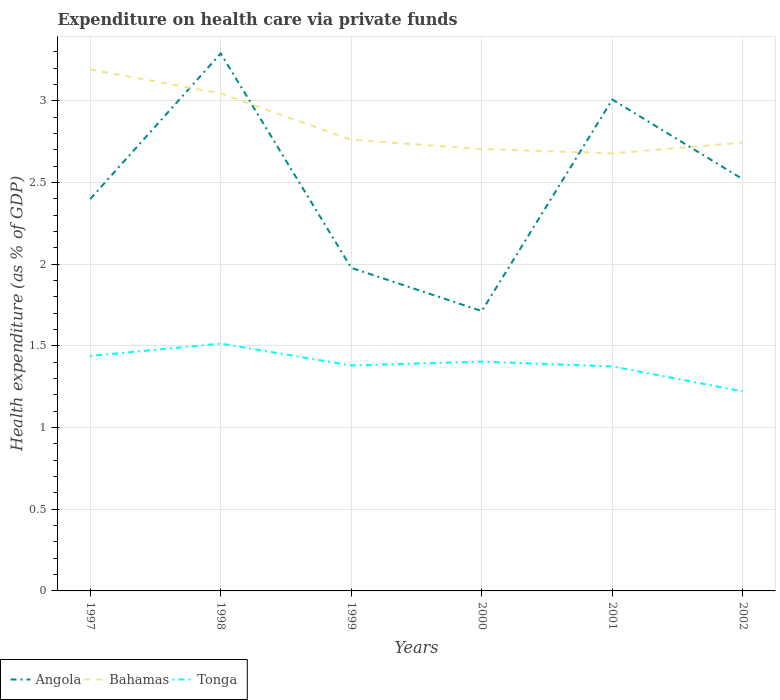Does the line corresponding to Angola intersect with the line corresponding to Bahamas?
Make the answer very short. Yes. Across all years, what is the maximum expenditure made on health care in Angola?
Provide a succinct answer. 1.71. In which year was the expenditure made on health care in Bahamas maximum?
Offer a terse response. 2001. What is the total expenditure made on health care in Bahamas in the graph?
Make the answer very short. 0.34. What is the difference between the highest and the second highest expenditure made on health care in Bahamas?
Your answer should be very brief. 0.51. How many years are there in the graph?
Provide a succinct answer. 6. Does the graph contain any zero values?
Offer a very short reply. No. Where does the legend appear in the graph?
Make the answer very short. Bottom left. How many legend labels are there?
Offer a terse response. 3. How are the legend labels stacked?
Provide a succinct answer. Horizontal. What is the title of the graph?
Offer a very short reply. Expenditure on health care via private funds. What is the label or title of the Y-axis?
Provide a short and direct response. Health expenditure (as % of GDP). What is the Health expenditure (as % of GDP) in Angola in 1997?
Offer a terse response. 2.4. What is the Health expenditure (as % of GDP) in Bahamas in 1997?
Offer a very short reply. 3.19. What is the Health expenditure (as % of GDP) in Tonga in 1997?
Your response must be concise. 1.44. What is the Health expenditure (as % of GDP) of Angola in 1998?
Provide a short and direct response. 3.29. What is the Health expenditure (as % of GDP) of Bahamas in 1998?
Make the answer very short. 3.05. What is the Health expenditure (as % of GDP) of Tonga in 1998?
Provide a succinct answer. 1.51. What is the Health expenditure (as % of GDP) in Angola in 1999?
Provide a succinct answer. 1.98. What is the Health expenditure (as % of GDP) in Bahamas in 1999?
Your answer should be very brief. 2.76. What is the Health expenditure (as % of GDP) of Tonga in 1999?
Offer a terse response. 1.38. What is the Health expenditure (as % of GDP) of Angola in 2000?
Keep it short and to the point. 1.71. What is the Health expenditure (as % of GDP) of Bahamas in 2000?
Your answer should be compact. 2.71. What is the Health expenditure (as % of GDP) in Tonga in 2000?
Keep it short and to the point. 1.4. What is the Health expenditure (as % of GDP) in Angola in 2001?
Keep it short and to the point. 3.01. What is the Health expenditure (as % of GDP) in Bahamas in 2001?
Make the answer very short. 2.68. What is the Health expenditure (as % of GDP) in Tonga in 2001?
Make the answer very short. 1.37. What is the Health expenditure (as % of GDP) in Angola in 2002?
Your response must be concise. 2.52. What is the Health expenditure (as % of GDP) in Bahamas in 2002?
Offer a terse response. 2.75. What is the Health expenditure (as % of GDP) of Tonga in 2002?
Give a very brief answer. 1.22. Across all years, what is the maximum Health expenditure (as % of GDP) of Angola?
Provide a short and direct response. 3.29. Across all years, what is the maximum Health expenditure (as % of GDP) of Bahamas?
Your response must be concise. 3.19. Across all years, what is the maximum Health expenditure (as % of GDP) in Tonga?
Ensure brevity in your answer.  1.51. Across all years, what is the minimum Health expenditure (as % of GDP) of Angola?
Your answer should be very brief. 1.71. Across all years, what is the minimum Health expenditure (as % of GDP) of Bahamas?
Offer a terse response. 2.68. Across all years, what is the minimum Health expenditure (as % of GDP) in Tonga?
Provide a short and direct response. 1.22. What is the total Health expenditure (as % of GDP) of Angola in the graph?
Make the answer very short. 14.91. What is the total Health expenditure (as % of GDP) in Bahamas in the graph?
Your answer should be very brief. 17.13. What is the total Health expenditure (as % of GDP) in Tonga in the graph?
Make the answer very short. 8.33. What is the difference between the Health expenditure (as % of GDP) of Angola in 1997 and that in 1998?
Offer a very short reply. -0.89. What is the difference between the Health expenditure (as % of GDP) in Bahamas in 1997 and that in 1998?
Your answer should be compact. 0.15. What is the difference between the Health expenditure (as % of GDP) in Tonga in 1997 and that in 1998?
Your response must be concise. -0.08. What is the difference between the Health expenditure (as % of GDP) of Angola in 1997 and that in 1999?
Your answer should be compact. 0.42. What is the difference between the Health expenditure (as % of GDP) in Bahamas in 1997 and that in 1999?
Make the answer very short. 0.43. What is the difference between the Health expenditure (as % of GDP) in Tonga in 1997 and that in 1999?
Your answer should be very brief. 0.06. What is the difference between the Health expenditure (as % of GDP) of Angola in 1997 and that in 2000?
Keep it short and to the point. 0.69. What is the difference between the Health expenditure (as % of GDP) of Bahamas in 1997 and that in 2000?
Give a very brief answer. 0.49. What is the difference between the Health expenditure (as % of GDP) of Tonga in 1997 and that in 2000?
Provide a succinct answer. 0.03. What is the difference between the Health expenditure (as % of GDP) in Angola in 1997 and that in 2001?
Your answer should be compact. -0.61. What is the difference between the Health expenditure (as % of GDP) in Bahamas in 1997 and that in 2001?
Provide a short and direct response. 0.51. What is the difference between the Health expenditure (as % of GDP) in Tonga in 1997 and that in 2001?
Ensure brevity in your answer.  0.06. What is the difference between the Health expenditure (as % of GDP) of Angola in 1997 and that in 2002?
Your response must be concise. -0.12. What is the difference between the Health expenditure (as % of GDP) of Bahamas in 1997 and that in 2002?
Ensure brevity in your answer.  0.45. What is the difference between the Health expenditure (as % of GDP) of Tonga in 1997 and that in 2002?
Provide a succinct answer. 0.22. What is the difference between the Health expenditure (as % of GDP) in Angola in 1998 and that in 1999?
Ensure brevity in your answer.  1.31. What is the difference between the Health expenditure (as % of GDP) in Bahamas in 1998 and that in 1999?
Give a very brief answer. 0.28. What is the difference between the Health expenditure (as % of GDP) in Tonga in 1998 and that in 1999?
Your answer should be compact. 0.13. What is the difference between the Health expenditure (as % of GDP) of Angola in 1998 and that in 2000?
Your answer should be compact. 1.58. What is the difference between the Health expenditure (as % of GDP) in Bahamas in 1998 and that in 2000?
Make the answer very short. 0.34. What is the difference between the Health expenditure (as % of GDP) in Tonga in 1998 and that in 2000?
Keep it short and to the point. 0.11. What is the difference between the Health expenditure (as % of GDP) in Angola in 1998 and that in 2001?
Provide a succinct answer. 0.28. What is the difference between the Health expenditure (as % of GDP) in Bahamas in 1998 and that in 2001?
Your answer should be very brief. 0.37. What is the difference between the Health expenditure (as % of GDP) of Tonga in 1998 and that in 2001?
Your response must be concise. 0.14. What is the difference between the Health expenditure (as % of GDP) in Angola in 1998 and that in 2002?
Your answer should be compact. 0.77. What is the difference between the Health expenditure (as % of GDP) of Bahamas in 1998 and that in 2002?
Your answer should be very brief. 0.3. What is the difference between the Health expenditure (as % of GDP) of Tonga in 1998 and that in 2002?
Provide a succinct answer. 0.29. What is the difference between the Health expenditure (as % of GDP) in Angola in 1999 and that in 2000?
Your answer should be very brief. 0.26. What is the difference between the Health expenditure (as % of GDP) in Bahamas in 1999 and that in 2000?
Offer a terse response. 0.06. What is the difference between the Health expenditure (as % of GDP) of Tonga in 1999 and that in 2000?
Offer a very short reply. -0.02. What is the difference between the Health expenditure (as % of GDP) in Angola in 1999 and that in 2001?
Ensure brevity in your answer.  -1.03. What is the difference between the Health expenditure (as % of GDP) in Bahamas in 1999 and that in 2001?
Provide a short and direct response. 0.08. What is the difference between the Health expenditure (as % of GDP) in Tonga in 1999 and that in 2001?
Give a very brief answer. 0.01. What is the difference between the Health expenditure (as % of GDP) in Angola in 1999 and that in 2002?
Keep it short and to the point. -0.54. What is the difference between the Health expenditure (as % of GDP) of Bahamas in 1999 and that in 2002?
Make the answer very short. 0.02. What is the difference between the Health expenditure (as % of GDP) of Tonga in 1999 and that in 2002?
Your answer should be very brief. 0.16. What is the difference between the Health expenditure (as % of GDP) of Angola in 2000 and that in 2001?
Offer a very short reply. -1.3. What is the difference between the Health expenditure (as % of GDP) in Bahamas in 2000 and that in 2001?
Your answer should be compact. 0.03. What is the difference between the Health expenditure (as % of GDP) in Tonga in 2000 and that in 2001?
Offer a terse response. 0.03. What is the difference between the Health expenditure (as % of GDP) in Angola in 2000 and that in 2002?
Your response must be concise. -0.81. What is the difference between the Health expenditure (as % of GDP) of Bahamas in 2000 and that in 2002?
Offer a very short reply. -0.04. What is the difference between the Health expenditure (as % of GDP) in Tonga in 2000 and that in 2002?
Keep it short and to the point. 0.18. What is the difference between the Health expenditure (as % of GDP) of Angola in 2001 and that in 2002?
Make the answer very short. 0.49. What is the difference between the Health expenditure (as % of GDP) of Bahamas in 2001 and that in 2002?
Give a very brief answer. -0.07. What is the difference between the Health expenditure (as % of GDP) of Tonga in 2001 and that in 2002?
Your answer should be compact. 0.15. What is the difference between the Health expenditure (as % of GDP) of Angola in 1997 and the Health expenditure (as % of GDP) of Bahamas in 1998?
Your response must be concise. -0.65. What is the difference between the Health expenditure (as % of GDP) in Angola in 1997 and the Health expenditure (as % of GDP) in Tonga in 1998?
Give a very brief answer. 0.89. What is the difference between the Health expenditure (as % of GDP) of Bahamas in 1997 and the Health expenditure (as % of GDP) of Tonga in 1998?
Offer a terse response. 1.68. What is the difference between the Health expenditure (as % of GDP) in Angola in 1997 and the Health expenditure (as % of GDP) in Bahamas in 1999?
Your answer should be compact. -0.36. What is the difference between the Health expenditure (as % of GDP) in Angola in 1997 and the Health expenditure (as % of GDP) in Tonga in 1999?
Keep it short and to the point. 1.02. What is the difference between the Health expenditure (as % of GDP) in Bahamas in 1997 and the Health expenditure (as % of GDP) in Tonga in 1999?
Provide a succinct answer. 1.81. What is the difference between the Health expenditure (as % of GDP) of Angola in 1997 and the Health expenditure (as % of GDP) of Bahamas in 2000?
Provide a short and direct response. -0.31. What is the difference between the Health expenditure (as % of GDP) in Bahamas in 1997 and the Health expenditure (as % of GDP) in Tonga in 2000?
Make the answer very short. 1.79. What is the difference between the Health expenditure (as % of GDP) of Angola in 1997 and the Health expenditure (as % of GDP) of Bahamas in 2001?
Make the answer very short. -0.28. What is the difference between the Health expenditure (as % of GDP) of Bahamas in 1997 and the Health expenditure (as % of GDP) of Tonga in 2001?
Offer a very short reply. 1.82. What is the difference between the Health expenditure (as % of GDP) of Angola in 1997 and the Health expenditure (as % of GDP) of Bahamas in 2002?
Your answer should be very brief. -0.35. What is the difference between the Health expenditure (as % of GDP) of Angola in 1997 and the Health expenditure (as % of GDP) of Tonga in 2002?
Give a very brief answer. 1.18. What is the difference between the Health expenditure (as % of GDP) in Bahamas in 1997 and the Health expenditure (as % of GDP) in Tonga in 2002?
Your answer should be compact. 1.97. What is the difference between the Health expenditure (as % of GDP) in Angola in 1998 and the Health expenditure (as % of GDP) in Bahamas in 1999?
Keep it short and to the point. 0.53. What is the difference between the Health expenditure (as % of GDP) of Angola in 1998 and the Health expenditure (as % of GDP) of Tonga in 1999?
Offer a very short reply. 1.91. What is the difference between the Health expenditure (as % of GDP) of Bahamas in 1998 and the Health expenditure (as % of GDP) of Tonga in 1999?
Offer a very short reply. 1.67. What is the difference between the Health expenditure (as % of GDP) of Angola in 1998 and the Health expenditure (as % of GDP) of Bahamas in 2000?
Give a very brief answer. 0.59. What is the difference between the Health expenditure (as % of GDP) in Angola in 1998 and the Health expenditure (as % of GDP) in Tonga in 2000?
Keep it short and to the point. 1.89. What is the difference between the Health expenditure (as % of GDP) in Bahamas in 1998 and the Health expenditure (as % of GDP) in Tonga in 2000?
Your response must be concise. 1.64. What is the difference between the Health expenditure (as % of GDP) of Angola in 1998 and the Health expenditure (as % of GDP) of Bahamas in 2001?
Your answer should be very brief. 0.61. What is the difference between the Health expenditure (as % of GDP) of Angola in 1998 and the Health expenditure (as % of GDP) of Tonga in 2001?
Your response must be concise. 1.92. What is the difference between the Health expenditure (as % of GDP) of Bahamas in 1998 and the Health expenditure (as % of GDP) of Tonga in 2001?
Provide a succinct answer. 1.67. What is the difference between the Health expenditure (as % of GDP) of Angola in 1998 and the Health expenditure (as % of GDP) of Bahamas in 2002?
Give a very brief answer. 0.55. What is the difference between the Health expenditure (as % of GDP) of Angola in 1998 and the Health expenditure (as % of GDP) of Tonga in 2002?
Provide a succinct answer. 2.07. What is the difference between the Health expenditure (as % of GDP) in Bahamas in 1998 and the Health expenditure (as % of GDP) in Tonga in 2002?
Keep it short and to the point. 1.82. What is the difference between the Health expenditure (as % of GDP) in Angola in 1999 and the Health expenditure (as % of GDP) in Bahamas in 2000?
Ensure brevity in your answer.  -0.73. What is the difference between the Health expenditure (as % of GDP) of Angola in 1999 and the Health expenditure (as % of GDP) of Tonga in 2000?
Make the answer very short. 0.57. What is the difference between the Health expenditure (as % of GDP) in Bahamas in 1999 and the Health expenditure (as % of GDP) in Tonga in 2000?
Your answer should be compact. 1.36. What is the difference between the Health expenditure (as % of GDP) of Angola in 1999 and the Health expenditure (as % of GDP) of Bahamas in 2001?
Ensure brevity in your answer.  -0.7. What is the difference between the Health expenditure (as % of GDP) of Angola in 1999 and the Health expenditure (as % of GDP) of Tonga in 2001?
Provide a short and direct response. 0.6. What is the difference between the Health expenditure (as % of GDP) of Bahamas in 1999 and the Health expenditure (as % of GDP) of Tonga in 2001?
Keep it short and to the point. 1.39. What is the difference between the Health expenditure (as % of GDP) in Angola in 1999 and the Health expenditure (as % of GDP) in Bahamas in 2002?
Your answer should be compact. -0.77. What is the difference between the Health expenditure (as % of GDP) of Angola in 1999 and the Health expenditure (as % of GDP) of Tonga in 2002?
Keep it short and to the point. 0.76. What is the difference between the Health expenditure (as % of GDP) of Bahamas in 1999 and the Health expenditure (as % of GDP) of Tonga in 2002?
Offer a terse response. 1.54. What is the difference between the Health expenditure (as % of GDP) of Angola in 2000 and the Health expenditure (as % of GDP) of Bahamas in 2001?
Your response must be concise. -0.97. What is the difference between the Health expenditure (as % of GDP) in Angola in 2000 and the Health expenditure (as % of GDP) in Tonga in 2001?
Your answer should be compact. 0.34. What is the difference between the Health expenditure (as % of GDP) in Bahamas in 2000 and the Health expenditure (as % of GDP) in Tonga in 2001?
Ensure brevity in your answer.  1.33. What is the difference between the Health expenditure (as % of GDP) in Angola in 2000 and the Health expenditure (as % of GDP) in Bahamas in 2002?
Provide a short and direct response. -1.03. What is the difference between the Health expenditure (as % of GDP) of Angola in 2000 and the Health expenditure (as % of GDP) of Tonga in 2002?
Keep it short and to the point. 0.49. What is the difference between the Health expenditure (as % of GDP) of Bahamas in 2000 and the Health expenditure (as % of GDP) of Tonga in 2002?
Make the answer very short. 1.48. What is the difference between the Health expenditure (as % of GDP) in Angola in 2001 and the Health expenditure (as % of GDP) in Bahamas in 2002?
Ensure brevity in your answer.  0.26. What is the difference between the Health expenditure (as % of GDP) in Angola in 2001 and the Health expenditure (as % of GDP) in Tonga in 2002?
Your answer should be very brief. 1.79. What is the difference between the Health expenditure (as % of GDP) of Bahamas in 2001 and the Health expenditure (as % of GDP) of Tonga in 2002?
Ensure brevity in your answer.  1.46. What is the average Health expenditure (as % of GDP) of Angola per year?
Your answer should be compact. 2.49. What is the average Health expenditure (as % of GDP) of Bahamas per year?
Provide a succinct answer. 2.86. What is the average Health expenditure (as % of GDP) in Tonga per year?
Provide a short and direct response. 1.39. In the year 1997, what is the difference between the Health expenditure (as % of GDP) in Angola and Health expenditure (as % of GDP) in Bahamas?
Offer a very short reply. -0.79. In the year 1997, what is the difference between the Health expenditure (as % of GDP) in Angola and Health expenditure (as % of GDP) in Tonga?
Your answer should be very brief. 0.96. In the year 1997, what is the difference between the Health expenditure (as % of GDP) in Bahamas and Health expenditure (as % of GDP) in Tonga?
Your answer should be compact. 1.75. In the year 1998, what is the difference between the Health expenditure (as % of GDP) of Angola and Health expenditure (as % of GDP) of Bahamas?
Offer a very short reply. 0.24. In the year 1998, what is the difference between the Health expenditure (as % of GDP) in Angola and Health expenditure (as % of GDP) in Tonga?
Your answer should be compact. 1.78. In the year 1998, what is the difference between the Health expenditure (as % of GDP) in Bahamas and Health expenditure (as % of GDP) in Tonga?
Your answer should be compact. 1.53. In the year 1999, what is the difference between the Health expenditure (as % of GDP) of Angola and Health expenditure (as % of GDP) of Bahamas?
Give a very brief answer. -0.78. In the year 1999, what is the difference between the Health expenditure (as % of GDP) of Angola and Health expenditure (as % of GDP) of Tonga?
Ensure brevity in your answer.  0.6. In the year 1999, what is the difference between the Health expenditure (as % of GDP) of Bahamas and Health expenditure (as % of GDP) of Tonga?
Your response must be concise. 1.38. In the year 2000, what is the difference between the Health expenditure (as % of GDP) in Angola and Health expenditure (as % of GDP) in Bahamas?
Provide a succinct answer. -0.99. In the year 2000, what is the difference between the Health expenditure (as % of GDP) of Angola and Health expenditure (as % of GDP) of Tonga?
Keep it short and to the point. 0.31. In the year 2000, what is the difference between the Health expenditure (as % of GDP) in Bahamas and Health expenditure (as % of GDP) in Tonga?
Provide a short and direct response. 1.3. In the year 2001, what is the difference between the Health expenditure (as % of GDP) in Angola and Health expenditure (as % of GDP) in Bahamas?
Your answer should be very brief. 0.33. In the year 2001, what is the difference between the Health expenditure (as % of GDP) of Angola and Health expenditure (as % of GDP) of Tonga?
Offer a very short reply. 1.63. In the year 2001, what is the difference between the Health expenditure (as % of GDP) in Bahamas and Health expenditure (as % of GDP) in Tonga?
Offer a very short reply. 1.3. In the year 2002, what is the difference between the Health expenditure (as % of GDP) of Angola and Health expenditure (as % of GDP) of Bahamas?
Your response must be concise. -0.22. In the year 2002, what is the difference between the Health expenditure (as % of GDP) of Angola and Health expenditure (as % of GDP) of Tonga?
Make the answer very short. 1.3. In the year 2002, what is the difference between the Health expenditure (as % of GDP) of Bahamas and Health expenditure (as % of GDP) of Tonga?
Provide a succinct answer. 1.52. What is the ratio of the Health expenditure (as % of GDP) in Angola in 1997 to that in 1998?
Make the answer very short. 0.73. What is the ratio of the Health expenditure (as % of GDP) in Bahamas in 1997 to that in 1998?
Offer a terse response. 1.05. What is the ratio of the Health expenditure (as % of GDP) in Tonga in 1997 to that in 1998?
Your answer should be very brief. 0.95. What is the ratio of the Health expenditure (as % of GDP) of Angola in 1997 to that in 1999?
Ensure brevity in your answer.  1.21. What is the ratio of the Health expenditure (as % of GDP) in Bahamas in 1997 to that in 1999?
Your response must be concise. 1.16. What is the ratio of the Health expenditure (as % of GDP) of Tonga in 1997 to that in 1999?
Keep it short and to the point. 1.04. What is the ratio of the Health expenditure (as % of GDP) in Angola in 1997 to that in 2000?
Ensure brevity in your answer.  1.4. What is the ratio of the Health expenditure (as % of GDP) in Bahamas in 1997 to that in 2000?
Keep it short and to the point. 1.18. What is the ratio of the Health expenditure (as % of GDP) in Tonga in 1997 to that in 2000?
Make the answer very short. 1.02. What is the ratio of the Health expenditure (as % of GDP) of Angola in 1997 to that in 2001?
Keep it short and to the point. 0.8. What is the ratio of the Health expenditure (as % of GDP) in Bahamas in 1997 to that in 2001?
Provide a succinct answer. 1.19. What is the ratio of the Health expenditure (as % of GDP) in Tonga in 1997 to that in 2001?
Provide a short and direct response. 1.05. What is the ratio of the Health expenditure (as % of GDP) in Bahamas in 1997 to that in 2002?
Your response must be concise. 1.16. What is the ratio of the Health expenditure (as % of GDP) of Tonga in 1997 to that in 2002?
Offer a very short reply. 1.18. What is the ratio of the Health expenditure (as % of GDP) of Angola in 1998 to that in 1999?
Ensure brevity in your answer.  1.66. What is the ratio of the Health expenditure (as % of GDP) of Bahamas in 1998 to that in 1999?
Offer a very short reply. 1.1. What is the ratio of the Health expenditure (as % of GDP) in Tonga in 1998 to that in 1999?
Provide a succinct answer. 1.1. What is the ratio of the Health expenditure (as % of GDP) in Angola in 1998 to that in 2000?
Your answer should be compact. 1.92. What is the ratio of the Health expenditure (as % of GDP) in Bahamas in 1998 to that in 2000?
Make the answer very short. 1.13. What is the ratio of the Health expenditure (as % of GDP) of Tonga in 1998 to that in 2000?
Ensure brevity in your answer.  1.08. What is the ratio of the Health expenditure (as % of GDP) in Angola in 1998 to that in 2001?
Ensure brevity in your answer.  1.09. What is the ratio of the Health expenditure (as % of GDP) in Bahamas in 1998 to that in 2001?
Make the answer very short. 1.14. What is the ratio of the Health expenditure (as % of GDP) of Tonga in 1998 to that in 2001?
Offer a very short reply. 1.1. What is the ratio of the Health expenditure (as % of GDP) of Angola in 1998 to that in 2002?
Your answer should be very brief. 1.31. What is the ratio of the Health expenditure (as % of GDP) in Bahamas in 1998 to that in 2002?
Provide a succinct answer. 1.11. What is the ratio of the Health expenditure (as % of GDP) in Tonga in 1998 to that in 2002?
Your answer should be compact. 1.24. What is the ratio of the Health expenditure (as % of GDP) of Angola in 1999 to that in 2000?
Your response must be concise. 1.15. What is the ratio of the Health expenditure (as % of GDP) of Angola in 1999 to that in 2001?
Offer a terse response. 0.66. What is the ratio of the Health expenditure (as % of GDP) of Bahamas in 1999 to that in 2001?
Offer a terse response. 1.03. What is the ratio of the Health expenditure (as % of GDP) of Angola in 1999 to that in 2002?
Your response must be concise. 0.78. What is the ratio of the Health expenditure (as % of GDP) in Bahamas in 1999 to that in 2002?
Offer a very short reply. 1.01. What is the ratio of the Health expenditure (as % of GDP) of Tonga in 1999 to that in 2002?
Provide a short and direct response. 1.13. What is the ratio of the Health expenditure (as % of GDP) of Angola in 2000 to that in 2001?
Keep it short and to the point. 0.57. What is the ratio of the Health expenditure (as % of GDP) in Bahamas in 2000 to that in 2001?
Keep it short and to the point. 1.01. What is the ratio of the Health expenditure (as % of GDP) in Tonga in 2000 to that in 2001?
Your answer should be very brief. 1.02. What is the ratio of the Health expenditure (as % of GDP) in Angola in 2000 to that in 2002?
Offer a very short reply. 0.68. What is the ratio of the Health expenditure (as % of GDP) of Bahamas in 2000 to that in 2002?
Keep it short and to the point. 0.99. What is the ratio of the Health expenditure (as % of GDP) in Tonga in 2000 to that in 2002?
Provide a succinct answer. 1.15. What is the ratio of the Health expenditure (as % of GDP) of Angola in 2001 to that in 2002?
Provide a short and direct response. 1.19. What is the ratio of the Health expenditure (as % of GDP) of Bahamas in 2001 to that in 2002?
Give a very brief answer. 0.98. What is the ratio of the Health expenditure (as % of GDP) of Tonga in 2001 to that in 2002?
Your response must be concise. 1.13. What is the difference between the highest and the second highest Health expenditure (as % of GDP) of Angola?
Your response must be concise. 0.28. What is the difference between the highest and the second highest Health expenditure (as % of GDP) in Bahamas?
Your response must be concise. 0.15. What is the difference between the highest and the second highest Health expenditure (as % of GDP) of Tonga?
Give a very brief answer. 0.08. What is the difference between the highest and the lowest Health expenditure (as % of GDP) of Angola?
Your answer should be very brief. 1.58. What is the difference between the highest and the lowest Health expenditure (as % of GDP) in Bahamas?
Your answer should be compact. 0.51. What is the difference between the highest and the lowest Health expenditure (as % of GDP) in Tonga?
Your response must be concise. 0.29. 